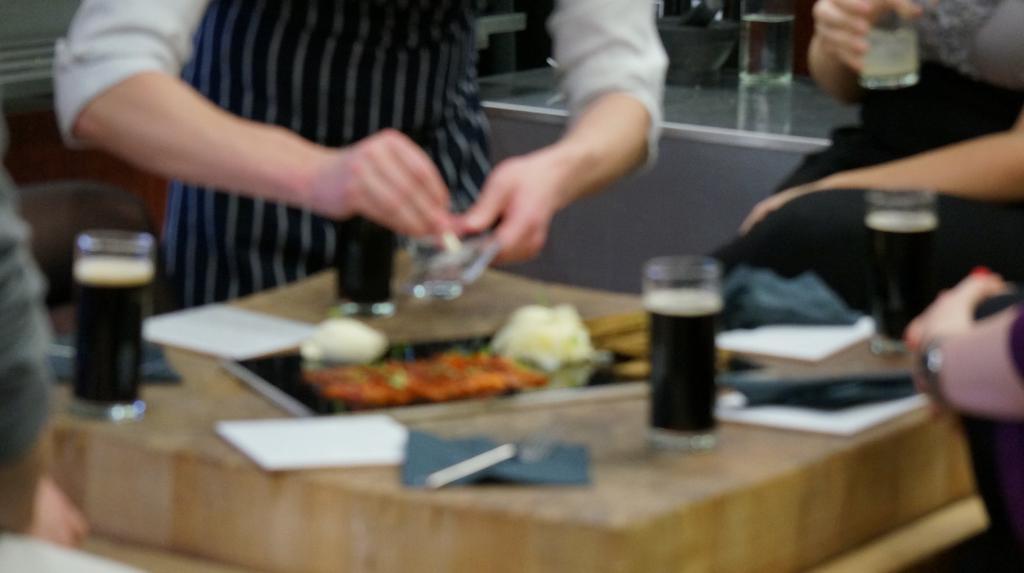Describe this image in one or two sentences. In a picture one man is standing and holding something in his hands in front of the table there are glasses and some food on it with some papers too and beside the table one woman is sitting and holding a glass and behind them there is a table and glass on it. 